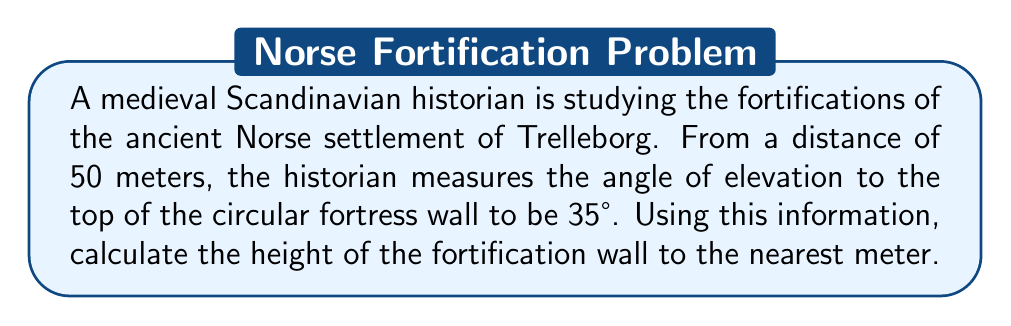Could you help me with this problem? To solve this problem, we'll use trigonometry, specifically the tangent function. Let's break it down step-by-step:

1) In a right triangle formed by the ground, the wall, and the line of sight:
   - The adjacent side is the distance from the historian to the wall (50 meters)
   - The opposite side is the height of the wall (what we're solving for)
   - The angle of elevation is 35°

2) The tangent of an angle in a right triangle is the ratio of the opposite side to the adjacent side:

   $$\tan(\theta) = \frac{\text{opposite}}{\text{adjacent}}$$

3) In this case:

   $$\tan(35°) = \frac{\text{height}}{50}$$

4) To solve for the height, we multiply both sides by 50:

   $$50 \cdot \tan(35°) = \text{height}$$

5) Now we can calculate:
   
   $$\text{height} = 50 \cdot \tan(35°) \approx 50 \cdot 0.7002 \approx 35.01$$

6) Rounding to the nearest meter:

   $$\text{height} \approx 35 \text{ meters}$$

Thus, the height of the Trelleborg fortification wall is approximately 35 meters.
Answer: 35 meters 